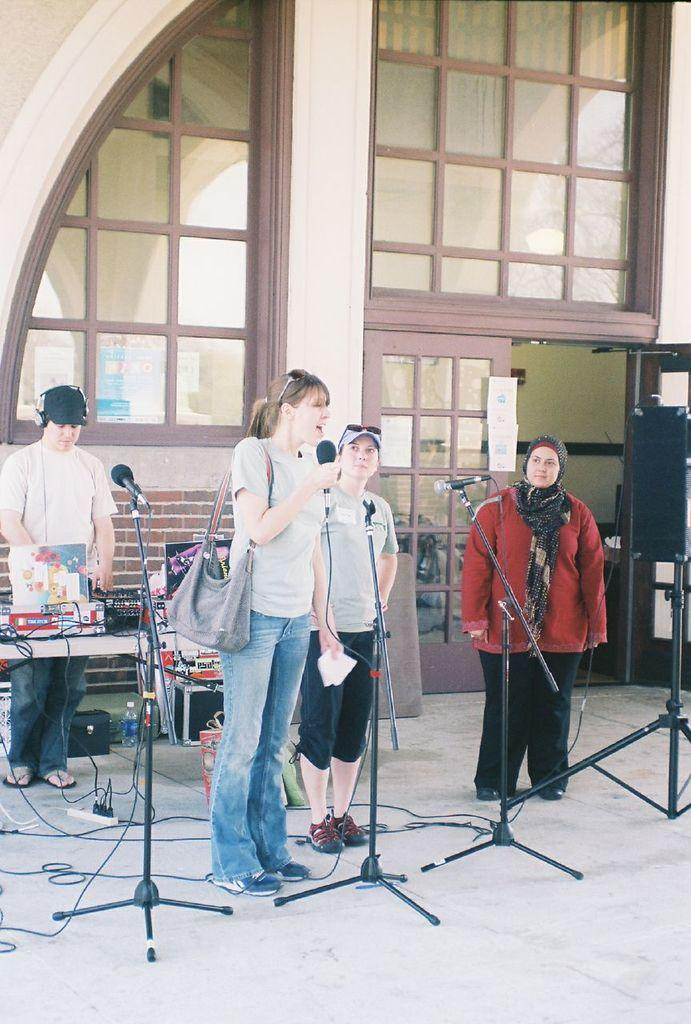How many people are in the image? There is a group of persons in the image. What are the persons doing in the image? The persons are standing on the floor. What objects are in front of the persons? There are microphones in front of the persons. What can be seen in the background of the image? There is a building in the background of the image. What type of muscle is visible on the persons in the image? There is no mention of muscles in the image, and the image does not show any visible muscles on the persons. 